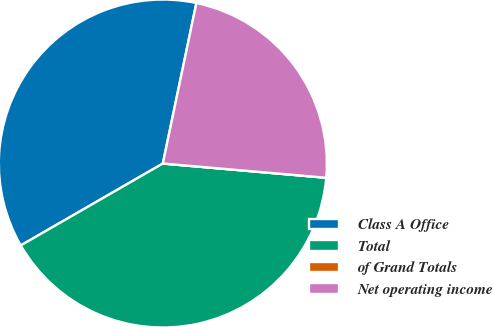Convert chart. <chart><loc_0><loc_0><loc_500><loc_500><pie_chart><fcel>Class A Office<fcel>Total<fcel>of Grand Totals<fcel>Net operating income<nl><fcel>36.6%<fcel>40.29%<fcel>0.0%<fcel>23.1%<nl></chart> 